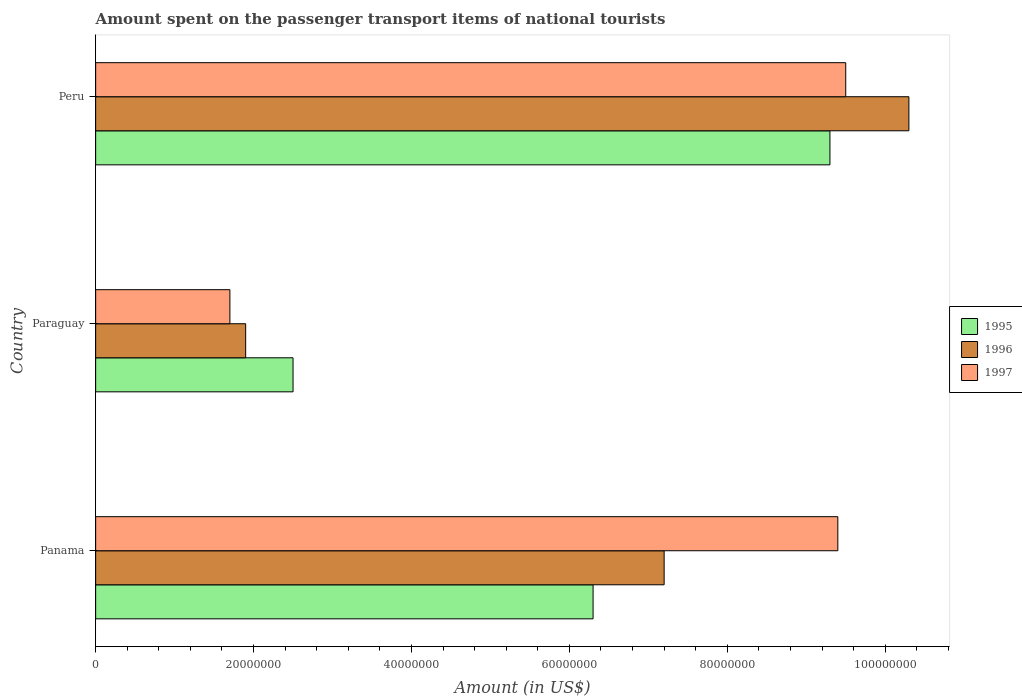How many different coloured bars are there?
Your answer should be very brief. 3. How many bars are there on the 3rd tick from the bottom?
Offer a very short reply. 3. What is the label of the 1st group of bars from the top?
Offer a terse response. Peru. What is the amount spent on the passenger transport items of national tourists in 1995 in Peru?
Offer a very short reply. 9.30e+07. Across all countries, what is the maximum amount spent on the passenger transport items of national tourists in 1997?
Give a very brief answer. 9.50e+07. Across all countries, what is the minimum amount spent on the passenger transport items of national tourists in 1995?
Keep it short and to the point. 2.50e+07. In which country was the amount spent on the passenger transport items of national tourists in 1995 maximum?
Provide a short and direct response. Peru. In which country was the amount spent on the passenger transport items of national tourists in 1996 minimum?
Your response must be concise. Paraguay. What is the total amount spent on the passenger transport items of national tourists in 1995 in the graph?
Offer a very short reply. 1.81e+08. What is the difference between the amount spent on the passenger transport items of national tourists in 1996 in Panama and that in Peru?
Offer a very short reply. -3.10e+07. What is the difference between the amount spent on the passenger transport items of national tourists in 1996 in Peru and the amount spent on the passenger transport items of national tourists in 1997 in Paraguay?
Your response must be concise. 8.60e+07. What is the average amount spent on the passenger transport items of national tourists in 1996 per country?
Offer a very short reply. 6.47e+07. What is the difference between the amount spent on the passenger transport items of national tourists in 1997 and amount spent on the passenger transport items of national tourists in 1995 in Peru?
Your answer should be compact. 2.00e+06. What is the ratio of the amount spent on the passenger transport items of national tourists in 1996 in Paraguay to that in Peru?
Give a very brief answer. 0.18. Is the amount spent on the passenger transport items of national tourists in 1995 in Panama less than that in Paraguay?
Provide a succinct answer. No. Is the difference between the amount spent on the passenger transport items of national tourists in 1997 in Paraguay and Peru greater than the difference between the amount spent on the passenger transport items of national tourists in 1995 in Paraguay and Peru?
Your response must be concise. No. What is the difference between the highest and the lowest amount spent on the passenger transport items of national tourists in 1995?
Your response must be concise. 6.80e+07. In how many countries, is the amount spent on the passenger transport items of national tourists in 1995 greater than the average amount spent on the passenger transport items of national tourists in 1995 taken over all countries?
Your response must be concise. 2. What does the 2nd bar from the bottom in Peru represents?
Provide a succinct answer. 1996. Is it the case that in every country, the sum of the amount spent on the passenger transport items of national tourists in 1997 and amount spent on the passenger transport items of national tourists in 1995 is greater than the amount spent on the passenger transport items of national tourists in 1996?
Provide a short and direct response. Yes. How many countries are there in the graph?
Your answer should be compact. 3. What is the difference between two consecutive major ticks on the X-axis?
Keep it short and to the point. 2.00e+07. Does the graph contain any zero values?
Provide a short and direct response. No. Does the graph contain grids?
Provide a short and direct response. No. How many legend labels are there?
Your answer should be compact. 3. What is the title of the graph?
Provide a succinct answer. Amount spent on the passenger transport items of national tourists. What is the label or title of the Y-axis?
Your answer should be very brief. Country. What is the Amount (in US$) of 1995 in Panama?
Provide a succinct answer. 6.30e+07. What is the Amount (in US$) in 1996 in Panama?
Your answer should be very brief. 7.20e+07. What is the Amount (in US$) of 1997 in Panama?
Your answer should be compact. 9.40e+07. What is the Amount (in US$) in 1995 in Paraguay?
Make the answer very short. 2.50e+07. What is the Amount (in US$) of 1996 in Paraguay?
Offer a terse response. 1.90e+07. What is the Amount (in US$) in 1997 in Paraguay?
Your answer should be very brief. 1.70e+07. What is the Amount (in US$) of 1995 in Peru?
Your response must be concise. 9.30e+07. What is the Amount (in US$) in 1996 in Peru?
Ensure brevity in your answer.  1.03e+08. What is the Amount (in US$) of 1997 in Peru?
Offer a terse response. 9.50e+07. Across all countries, what is the maximum Amount (in US$) of 1995?
Your answer should be compact. 9.30e+07. Across all countries, what is the maximum Amount (in US$) in 1996?
Your answer should be compact. 1.03e+08. Across all countries, what is the maximum Amount (in US$) in 1997?
Your response must be concise. 9.50e+07. Across all countries, what is the minimum Amount (in US$) of 1995?
Provide a short and direct response. 2.50e+07. Across all countries, what is the minimum Amount (in US$) of 1996?
Provide a succinct answer. 1.90e+07. Across all countries, what is the minimum Amount (in US$) of 1997?
Offer a very short reply. 1.70e+07. What is the total Amount (in US$) of 1995 in the graph?
Your answer should be compact. 1.81e+08. What is the total Amount (in US$) in 1996 in the graph?
Provide a short and direct response. 1.94e+08. What is the total Amount (in US$) in 1997 in the graph?
Your response must be concise. 2.06e+08. What is the difference between the Amount (in US$) in 1995 in Panama and that in Paraguay?
Offer a terse response. 3.80e+07. What is the difference between the Amount (in US$) in 1996 in Panama and that in Paraguay?
Make the answer very short. 5.30e+07. What is the difference between the Amount (in US$) of 1997 in Panama and that in Paraguay?
Your answer should be very brief. 7.70e+07. What is the difference between the Amount (in US$) in 1995 in Panama and that in Peru?
Offer a terse response. -3.00e+07. What is the difference between the Amount (in US$) in 1996 in Panama and that in Peru?
Provide a succinct answer. -3.10e+07. What is the difference between the Amount (in US$) in 1995 in Paraguay and that in Peru?
Ensure brevity in your answer.  -6.80e+07. What is the difference between the Amount (in US$) of 1996 in Paraguay and that in Peru?
Your answer should be compact. -8.40e+07. What is the difference between the Amount (in US$) of 1997 in Paraguay and that in Peru?
Make the answer very short. -7.80e+07. What is the difference between the Amount (in US$) in 1995 in Panama and the Amount (in US$) in 1996 in Paraguay?
Your answer should be compact. 4.40e+07. What is the difference between the Amount (in US$) in 1995 in Panama and the Amount (in US$) in 1997 in Paraguay?
Offer a terse response. 4.60e+07. What is the difference between the Amount (in US$) in 1996 in Panama and the Amount (in US$) in 1997 in Paraguay?
Provide a succinct answer. 5.50e+07. What is the difference between the Amount (in US$) in 1995 in Panama and the Amount (in US$) in 1996 in Peru?
Ensure brevity in your answer.  -4.00e+07. What is the difference between the Amount (in US$) in 1995 in Panama and the Amount (in US$) in 1997 in Peru?
Your answer should be very brief. -3.20e+07. What is the difference between the Amount (in US$) in 1996 in Panama and the Amount (in US$) in 1997 in Peru?
Your answer should be compact. -2.30e+07. What is the difference between the Amount (in US$) of 1995 in Paraguay and the Amount (in US$) of 1996 in Peru?
Provide a short and direct response. -7.80e+07. What is the difference between the Amount (in US$) in 1995 in Paraguay and the Amount (in US$) in 1997 in Peru?
Your response must be concise. -7.00e+07. What is the difference between the Amount (in US$) of 1996 in Paraguay and the Amount (in US$) of 1997 in Peru?
Your answer should be very brief. -7.60e+07. What is the average Amount (in US$) of 1995 per country?
Give a very brief answer. 6.03e+07. What is the average Amount (in US$) of 1996 per country?
Your answer should be compact. 6.47e+07. What is the average Amount (in US$) in 1997 per country?
Provide a succinct answer. 6.87e+07. What is the difference between the Amount (in US$) of 1995 and Amount (in US$) of 1996 in Panama?
Provide a succinct answer. -9.00e+06. What is the difference between the Amount (in US$) of 1995 and Amount (in US$) of 1997 in Panama?
Offer a very short reply. -3.10e+07. What is the difference between the Amount (in US$) in 1996 and Amount (in US$) in 1997 in Panama?
Your answer should be very brief. -2.20e+07. What is the difference between the Amount (in US$) in 1995 and Amount (in US$) in 1996 in Paraguay?
Provide a succinct answer. 6.00e+06. What is the difference between the Amount (in US$) in 1995 and Amount (in US$) in 1997 in Paraguay?
Ensure brevity in your answer.  8.00e+06. What is the difference between the Amount (in US$) of 1995 and Amount (in US$) of 1996 in Peru?
Make the answer very short. -1.00e+07. What is the difference between the Amount (in US$) in 1995 and Amount (in US$) in 1997 in Peru?
Provide a short and direct response. -2.00e+06. What is the difference between the Amount (in US$) in 1996 and Amount (in US$) in 1997 in Peru?
Your answer should be compact. 8.00e+06. What is the ratio of the Amount (in US$) in 1995 in Panama to that in Paraguay?
Your answer should be compact. 2.52. What is the ratio of the Amount (in US$) of 1996 in Panama to that in Paraguay?
Provide a succinct answer. 3.79. What is the ratio of the Amount (in US$) of 1997 in Panama to that in Paraguay?
Give a very brief answer. 5.53. What is the ratio of the Amount (in US$) of 1995 in Panama to that in Peru?
Keep it short and to the point. 0.68. What is the ratio of the Amount (in US$) in 1996 in Panama to that in Peru?
Provide a short and direct response. 0.7. What is the ratio of the Amount (in US$) of 1997 in Panama to that in Peru?
Offer a terse response. 0.99. What is the ratio of the Amount (in US$) of 1995 in Paraguay to that in Peru?
Provide a short and direct response. 0.27. What is the ratio of the Amount (in US$) in 1996 in Paraguay to that in Peru?
Make the answer very short. 0.18. What is the ratio of the Amount (in US$) in 1997 in Paraguay to that in Peru?
Your answer should be very brief. 0.18. What is the difference between the highest and the second highest Amount (in US$) of 1995?
Provide a succinct answer. 3.00e+07. What is the difference between the highest and the second highest Amount (in US$) of 1996?
Your answer should be compact. 3.10e+07. What is the difference between the highest and the second highest Amount (in US$) in 1997?
Provide a short and direct response. 1.00e+06. What is the difference between the highest and the lowest Amount (in US$) in 1995?
Ensure brevity in your answer.  6.80e+07. What is the difference between the highest and the lowest Amount (in US$) in 1996?
Make the answer very short. 8.40e+07. What is the difference between the highest and the lowest Amount (in US$) in 1997?
Keep it short and to the point. 7.80e+07. 